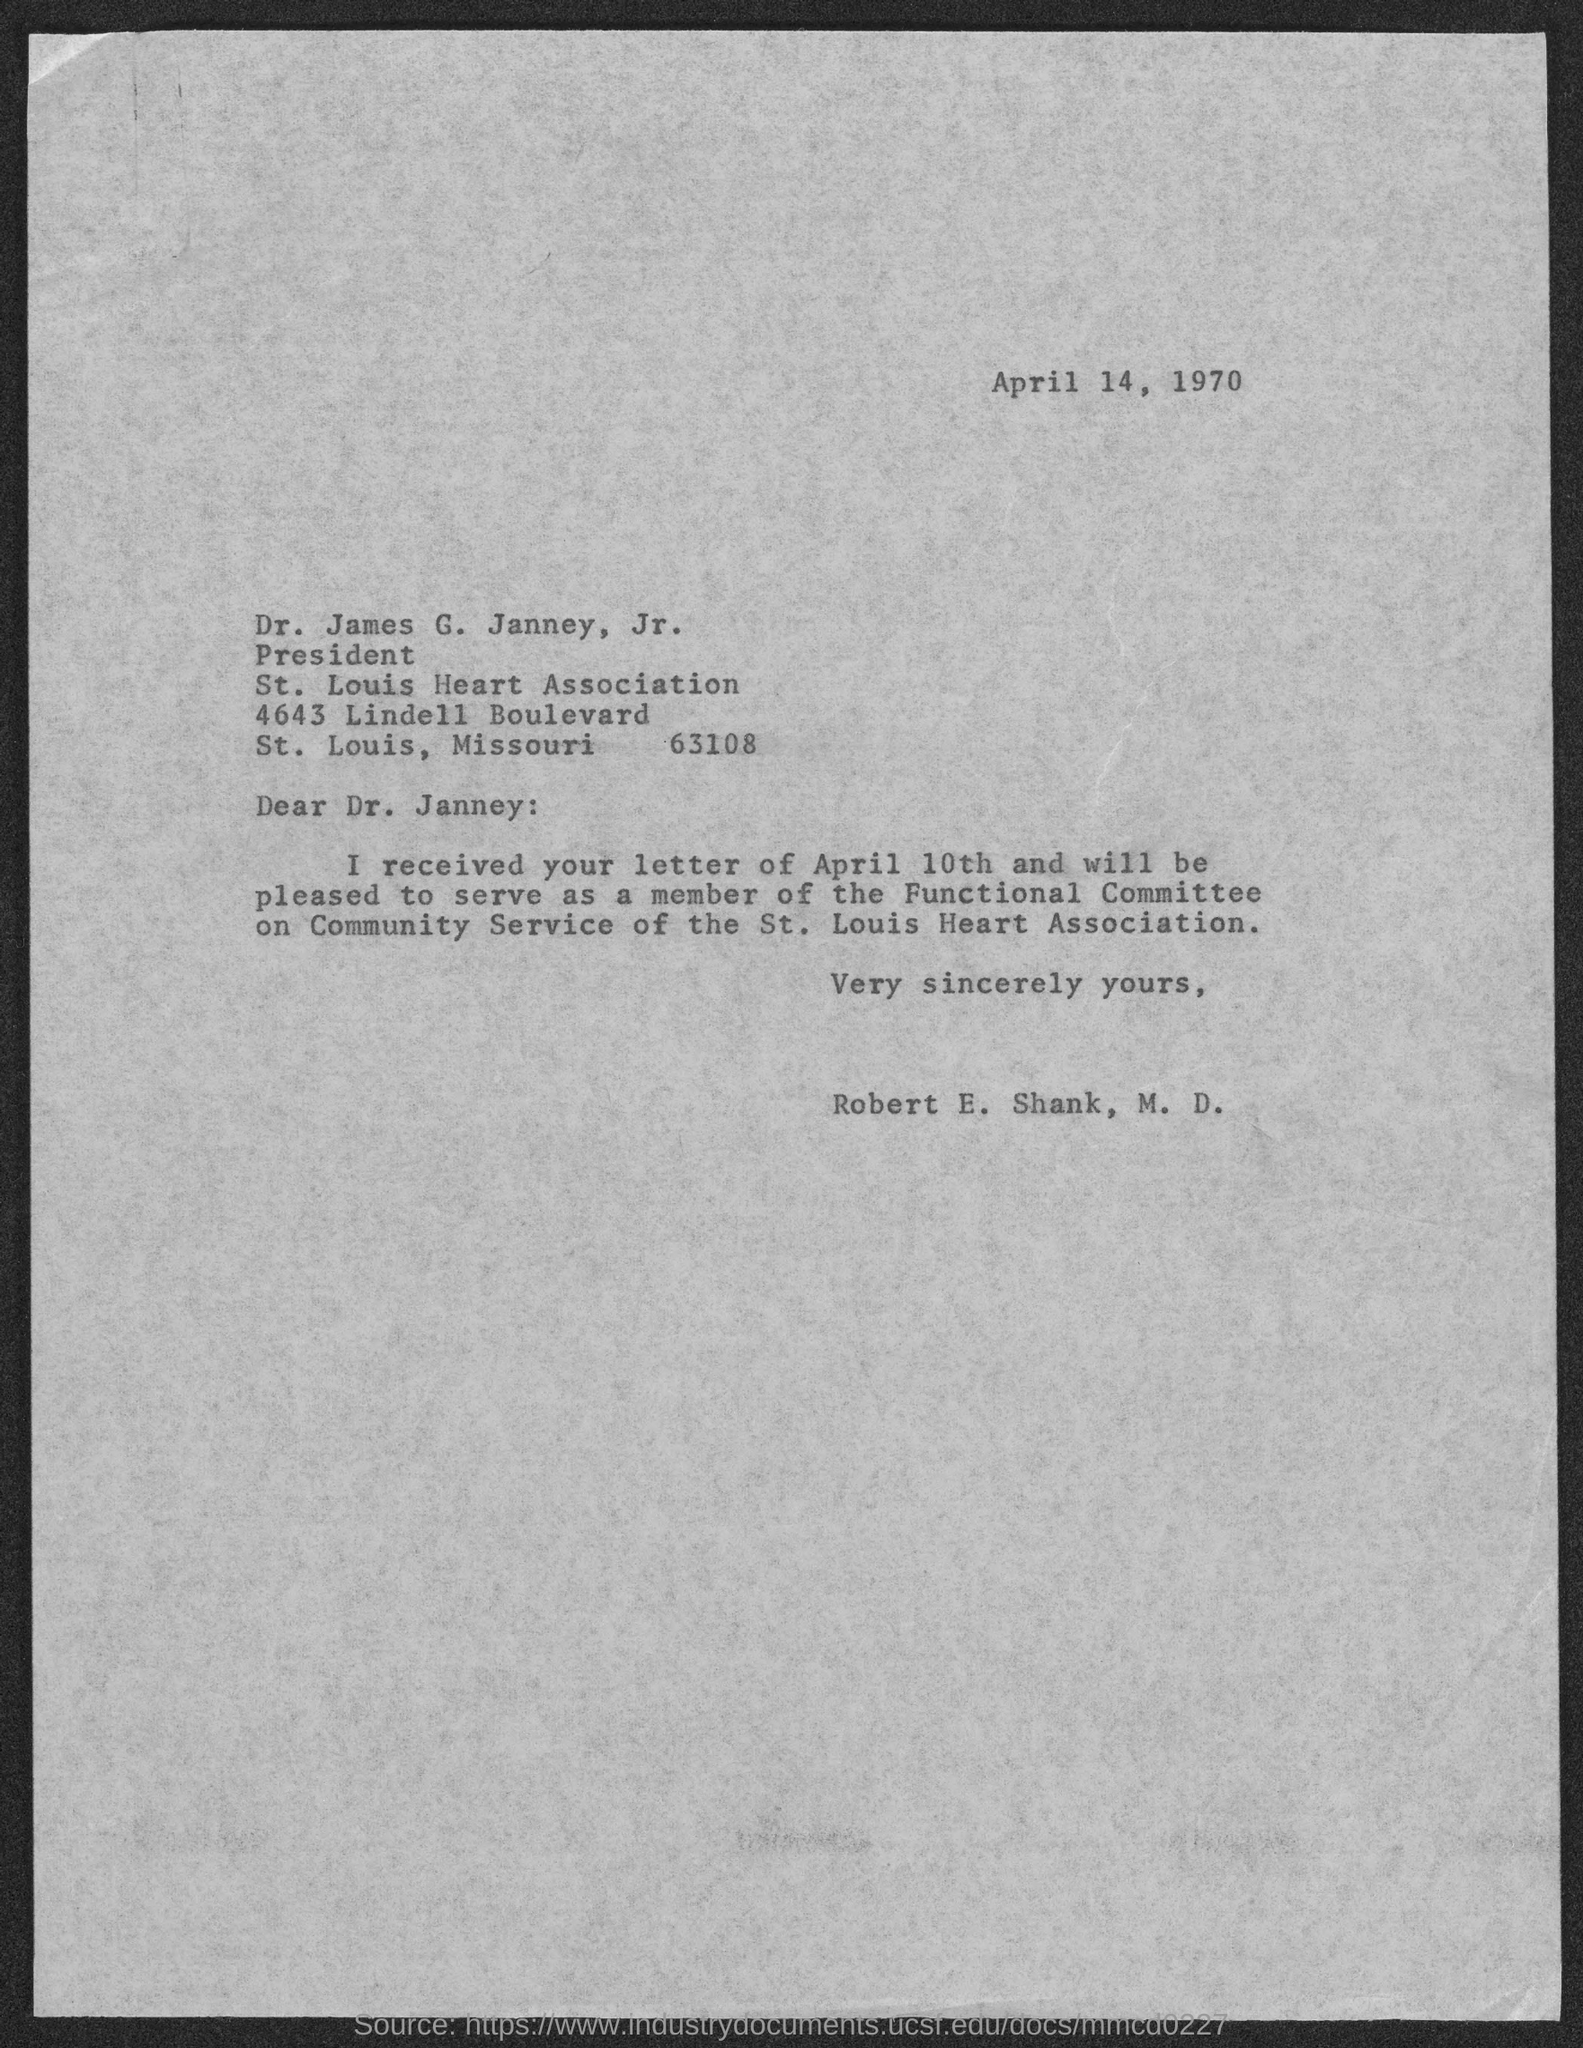Identify some key points in this picture. On April 14, 1970, the letter was dated. The writer of the letter is Dr. Robert E. Shank, a medical doctor. The person to whom this letter is addressed is Dr. James G. Janney, Jr. I, Robert E. Shank, M.D., am volunteering to serve as a member of the Functional Committee. The postal code of the St. Louis Heart Association is 63108. 